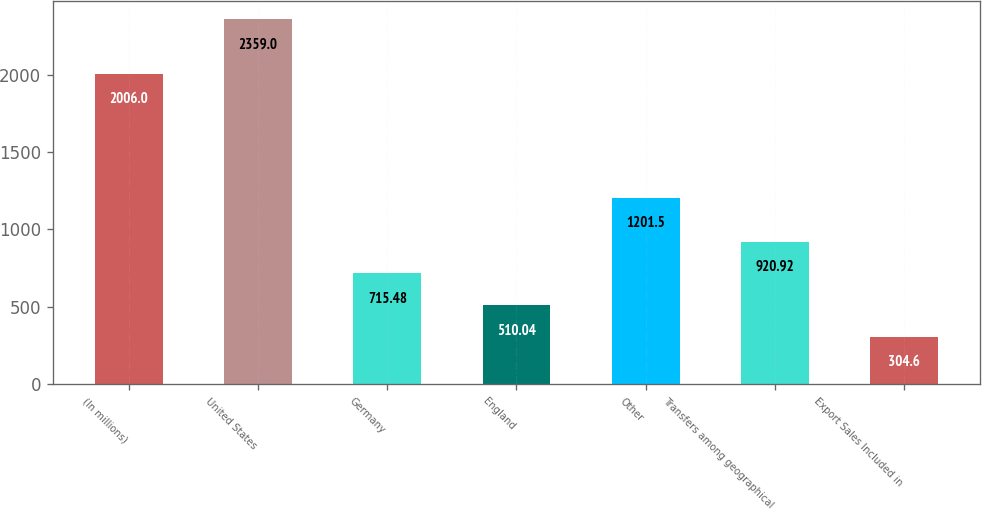Convert chart to OTSL. <chart><loc_0><loc_0><loc_500><loc_500><bar_chart><fcel>(In millions)<fcel>United States<fcel>Germany<fcel>England<fcel>Other<fcel>Transfers among geographical<fcel>Export Sales Included in<nl><fcel>2006<fcel>2359<fcel>715.48<fcel>510.04<fcel>1201.5<fcel>920.92<fcel>304.6<nl></chart> 